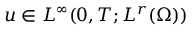Convert formula to latex. <formula><loc_0><loc_0><loc_500><loc_500>u \in L ^ { \infty } ( 0 , T ; L ^ { r } ( \Omega ) )</formula> 